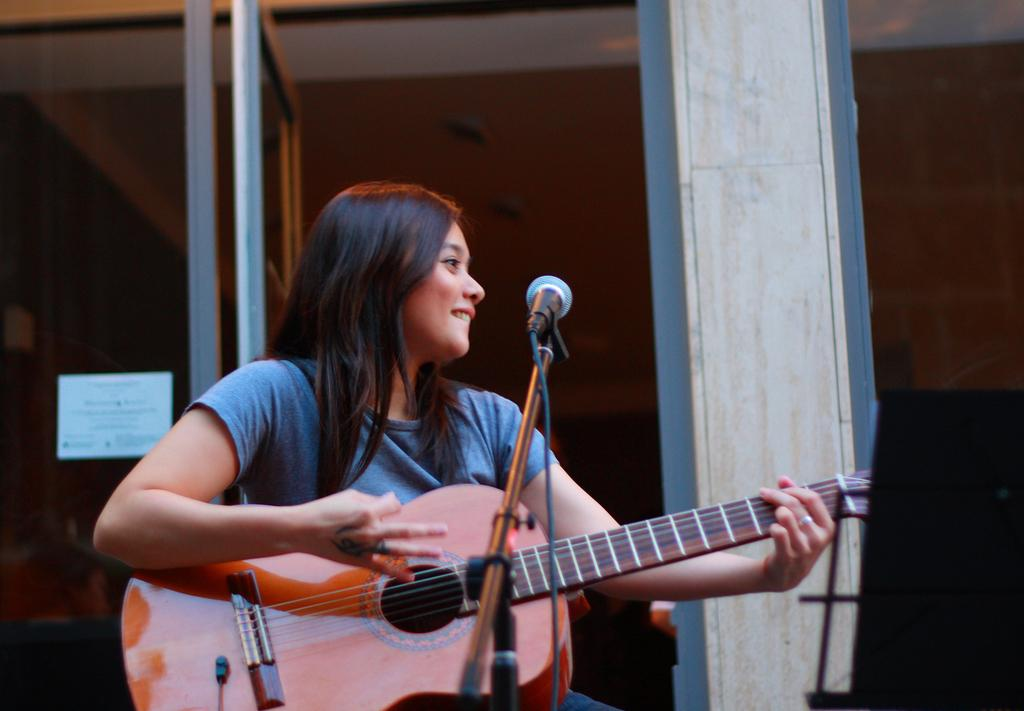Who is the main subject in the image? There is a woman in the image. What is the woman doing in the image? The woman is playing a guitar. What is the woman's facial expression in the image? The woman is smiling. What other objects can be seen in the image? There is a microphone (mike) and a screen in the image. Can you see any wilderness or rays in the image? No, there is no wilderness or rays present in the image. 